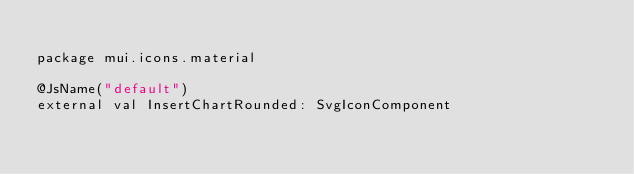Convert code to text. <code><loc_0><loc_0><loc_500><loc_500><_Kotlin_>
package mui.icons.material

@JsName("default")
external val InsertChartRounded: SvgIconComponent
</code> 